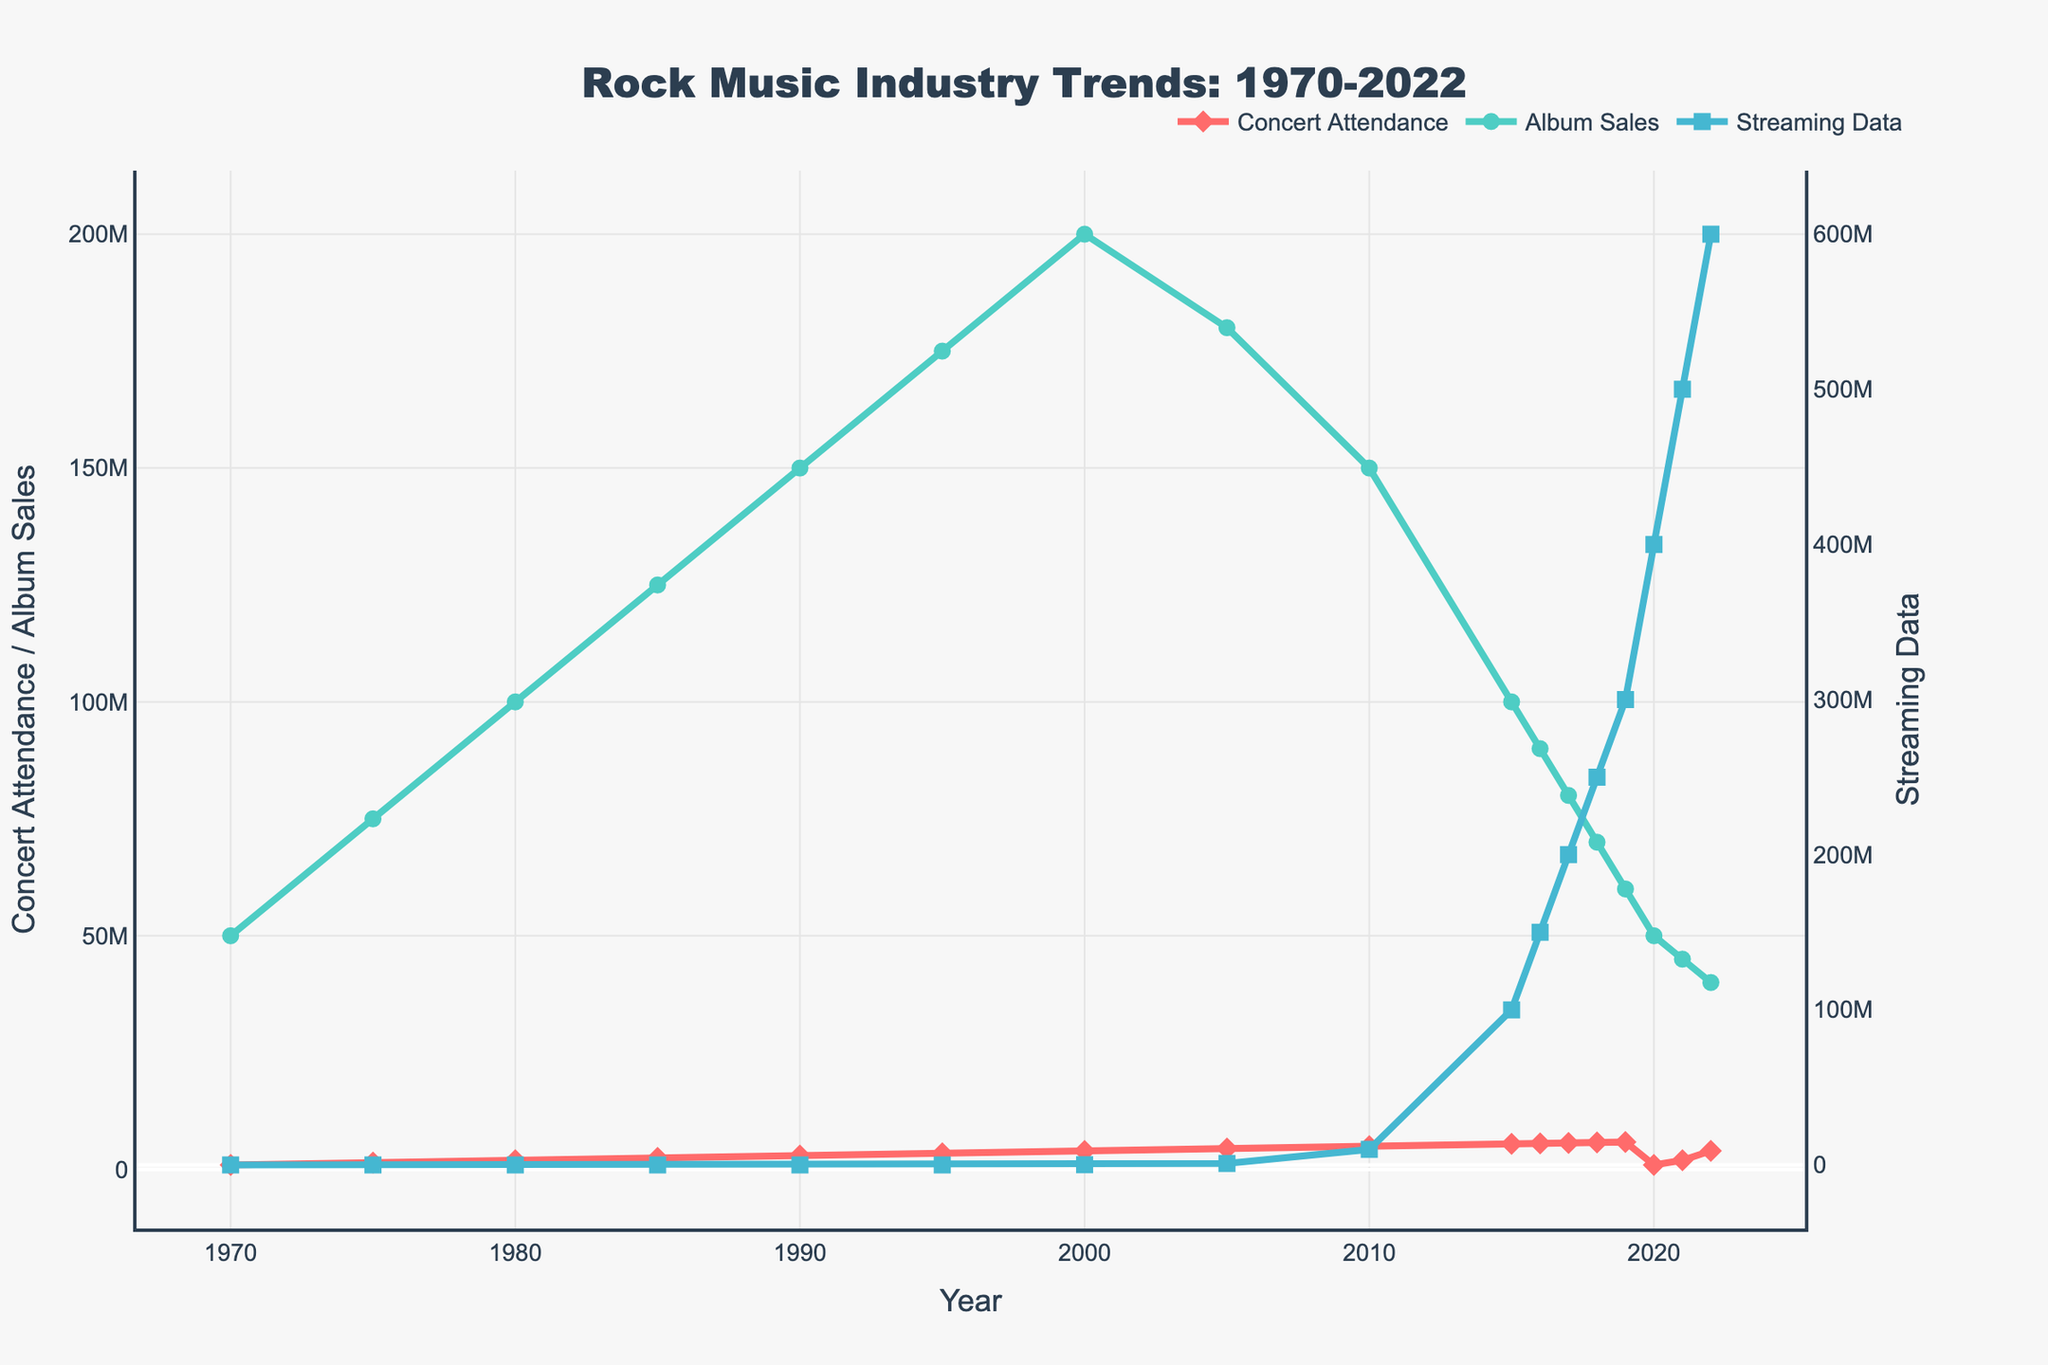What was the concert attendance in 1990? By looking at the "Concert Attendance" line, we see it reaches 3,000,000 in 1990.
Answer: 3,000,000 How did album sales change from 2000 to 2005? By comparing the "Album Sales" values in 2000 and 2005, we see it decreased from 200,000,000 to 180,000,000.
Answer: decreased by 20,000,000 When did streaming data first appear in the dataset, and what was its value at that time? Streaming data first appears in 2000, with a value of 100,000.
Answer: 2000, 100,000 What is the highest value for streaming data? By scanning the "Streaming Data" line, the highest value is 600,000,000 in 2022.
Answer: 600,000,000 Which year saw the highest concert attendance, and what was the value? The highest concert attendance is seen in 2019 with a value of 5,900,000.
Answer: 2019, 5,900,000 Compare album sales between 1980 and 2022. Album sales in 1980 were 100,000,000, whereas in 2022 they were 40,000,000.
Answer: 60,000,000 lower What was the trend in album sales from 2015 to 2022? Album sales declined steadily from 100,000,000 to 40,000,000 between 2015 and 2022.
Answer: declining trend What is the average concert attendance from 1970 to 1995? Add the attendance for the given years (1,000,000 + 1,500,000 + 2,000,000 + 2,500,000 + 3,000,000 + 3,500,000) and divide by 6. The sum is 13,500,000; the average is 13,500,000 / 6 = 2,250,000.
Answer: 2,250,000 Identify the trend in streaming data from 2010 to 2022. Streaming data steadily increased from 10,000,000 to 600,000,000 from 2010 to 2022.
Answer: increasing trend 